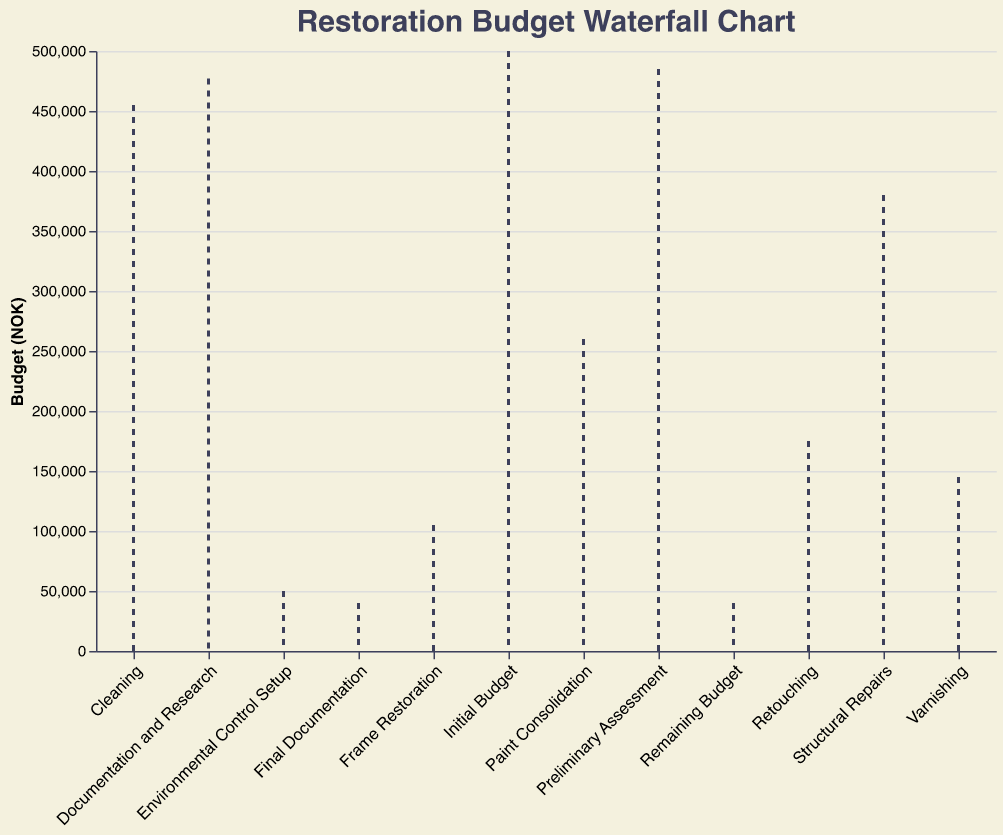What's the total amount spent on preliminary assessment? The value for the preliminary assessment is -15000 NOK, which represents spending.
Answer: 15000 NOK What is the title of the chart? The title of the chart is shown at the top and reads "Restoration Budget Waterfall Chart."
Answer: Restoration Budget Waterfall Chart How much was spent on structural repairs and paint consolidation combined? The value for structural repairs is -75000 NOK, and for paint consolidation, it is -120000 NOK. Adding these amounts gives the total spent: 75000 + 120000 = 195000 NOK.
Answer: 195000 NOK What stage incurred the highest single expense? Comparing all the negative values, paint consolidation has the highest value at -120000 NOK.
Answer: Paint Consolidation What is the remaining budget after all expenses? The final value under "Remaining Budget" is 40000 NOK, indicating the remaining budget.
Answer: 40000 NOK Which expense had the least impact on the budget? Among negative values, the preliminary assessment had the least impact at -15000 NOK.
Answer: Preliminary Assessment By how much did the frame restoration and environmental control setup reduce the budget? The value for frame restoration is -40000 NOK, and for environmental control setup, it is -55000 NOK. Adding these amounts: 40000 + 55000 = 95000 NOK.
Answer: 95000 NOK How much was spent on retouching and varnishing? The expense for retouching is -85000 NOK, and for varnishing, it is -30000 NOK. Summing these values: 85000 + 30000 = 115000 NOK.
Answer: 115000 NOK What are the color indications for expenses and budgets in the chart? The colors indicate that expenses (negative values) are shown in reddish hues, and the initial and remaining budgets are shown in greenish hues.
Answer: Expenses: Red; Budgets: Green Which stage follows the preliminary assessment in terms of budget reduction? Preliminary Assessment is followed by Documentation and Research, which has a value of -8000 NOK.
Answer: Documentation and Research 